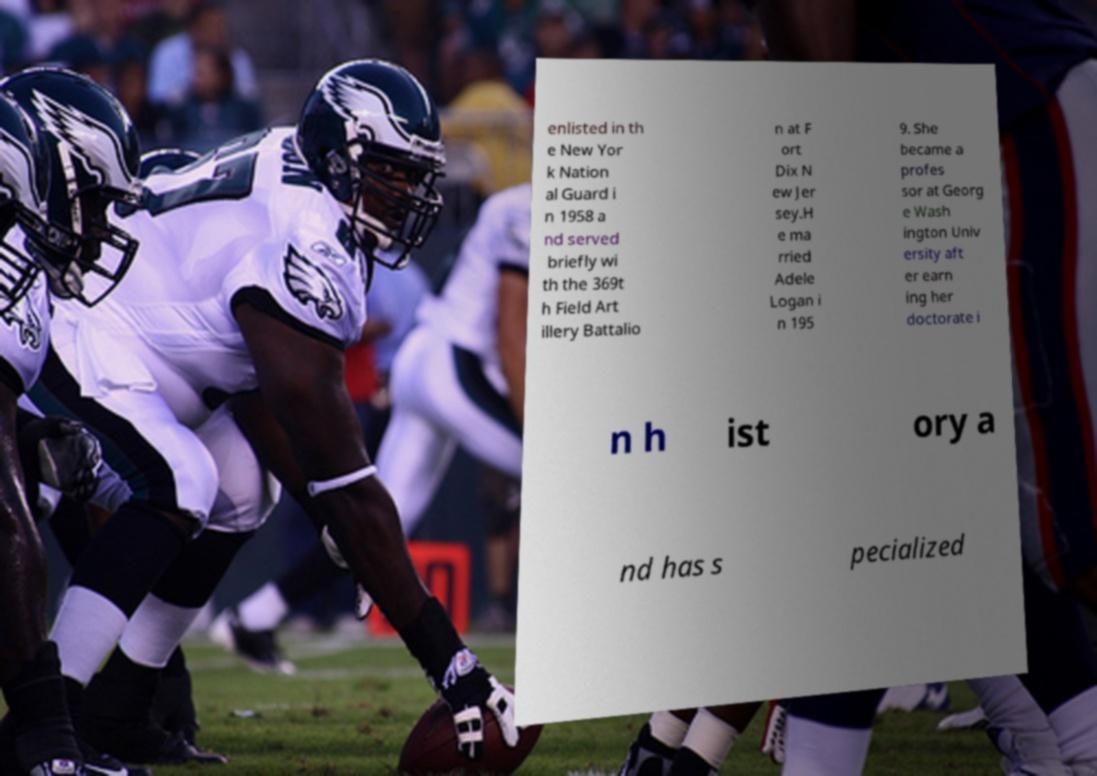Please identify and transcribe the text found in this image. enlisted in th e New Yor k Nation al Guard i n 1958 a nd served briefly wi th the 369t h Field Art illery Battalio n at F ort Dix N ew Jer sey.H e ma rried Adele Logan i n 195 9. She became a profes sor at Georg e Wash ington Univ ersity aft er earn ing her doctorate i n h ist ory a nd has s pecialized 